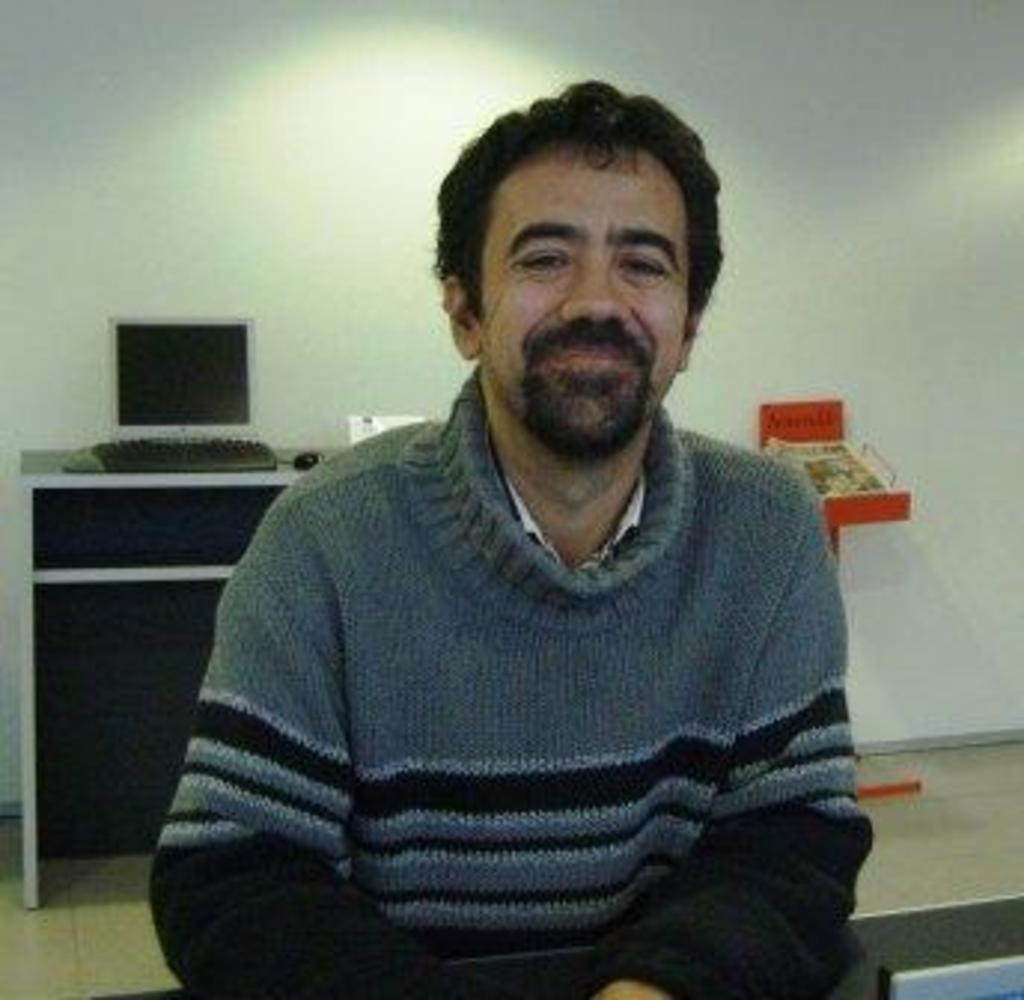Who or what is the main subject in the image? There is a person in the image. What is the person wearing? The person is wearing a sweater. What can be seen on the table in the image? A monitor, a keyboard, and a mouse are on the table. Are there any other objects on the table? Yes, there are additional objects on the table. What is visible in the background of the image? There is a wall in the background of the image. What type of shoes is the person wearing in the image? The facts provided do not mention shoes, so we cannot determine what type of shoes the person is wearing in the image. 